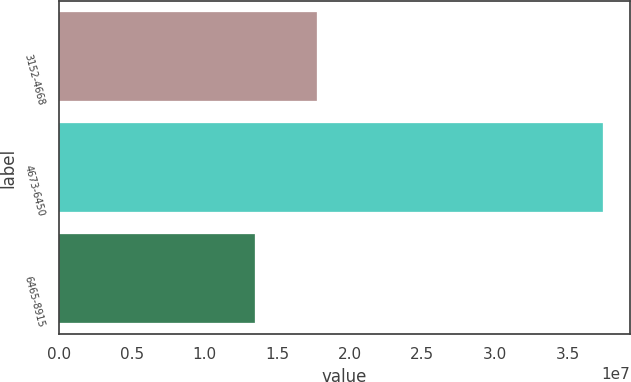<chart> <loc_0><loc_0><loc_500><loc_500><bar_chart><fcel>3152-4668<fcel>4673-6450<fcel>6465-8915<nl><fcel>1.77632e+07<fcel>3.74364e+07<fcel>1.35146e+07<nl></chart> 